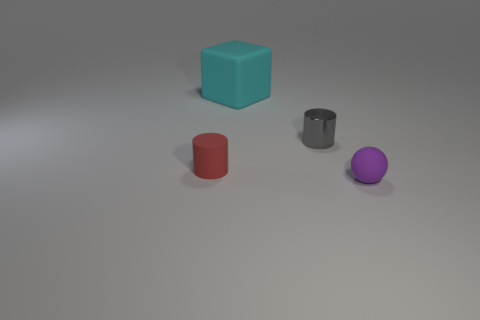Are there any cyan objects that are behind the cylinder to the left of the tiny gray shiny cylinder?
Offer a terse response. Yes. There is a gray metal thing; does it have the same shape as the small rubber thing behind the purple thing?
Your answer should be very brief. Yes. There is a object that is behind the red thing and to the left of the tiny gray object; what is its size?
Provide a short and direct response. Large. Is there a large purple cylinder that has the same material as the large cyan object?
Ensure brevity in your answer.  No. There is a small object that is left of the tiny object that is behind the red matte cylinder; what is it made of?
Offer a very short reply. Rubber. There is a cylinder that is made of the same material as the small purple thing; what size is it?
Your answer should be compact. Small. The tiny matte thing on the left side of the purple object has what shape?
Your answer should be very brief. Cylinder. The red rubber object that is the same shape as the metal object is what size?
Your response must be concise. Small. There is a small object that is in front of the small matte object that is behind the purple rubber ball; how many gray cylinders are behind it?
Your answer should be compact. 1. Are there an equal number of cylinders that are behind the rubber sphere and rubber spheres?
Offer a very short reply. No. 